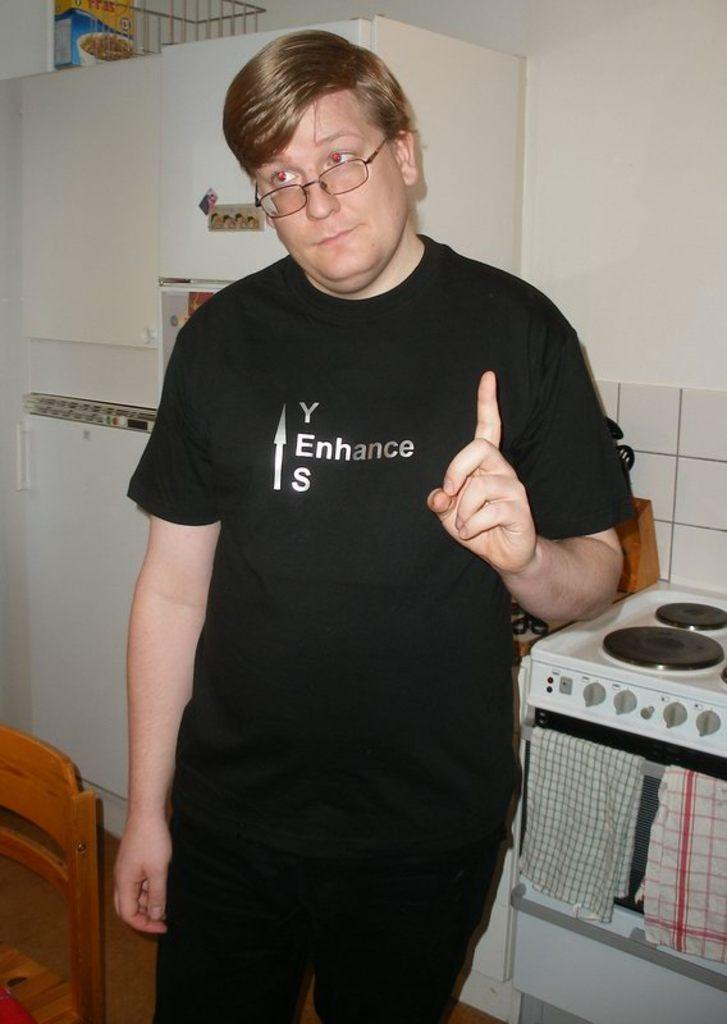<image>
Write a terse but informative summary of the picture. A man stands in a kitchen with a shirt that has the word enhance on it. 